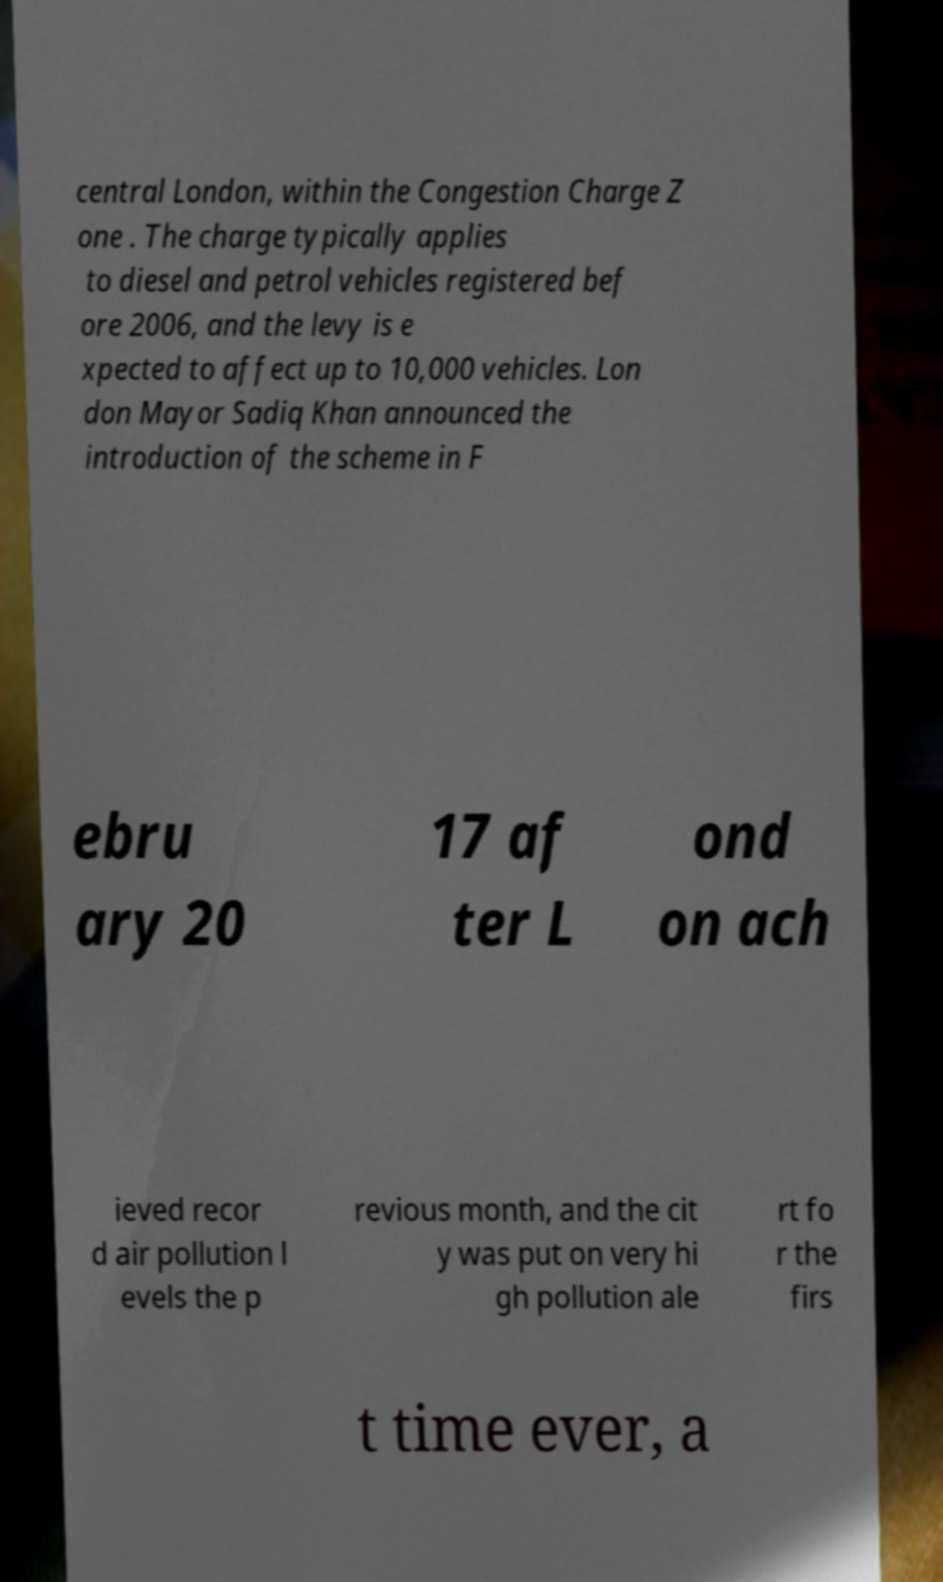There's text embedded in this image that I need extracted. Can you transcribe it verbatim? central London, within the Congestion Charge Z one . The charge typically applies to diesel and petrol vehicles registered bef ore 2006, and the levy is e xpected to affect up to 10,000 vehicles. Lon don Mayor Sadiq Khan announced the introduction of the scheme in F ebru ary 20 17 af ter L ond on ach ieved recor d air pollution l evels the p revious month, and the cit y was put on very hi gh pollution ale rt fo r the firs t time ever, a 